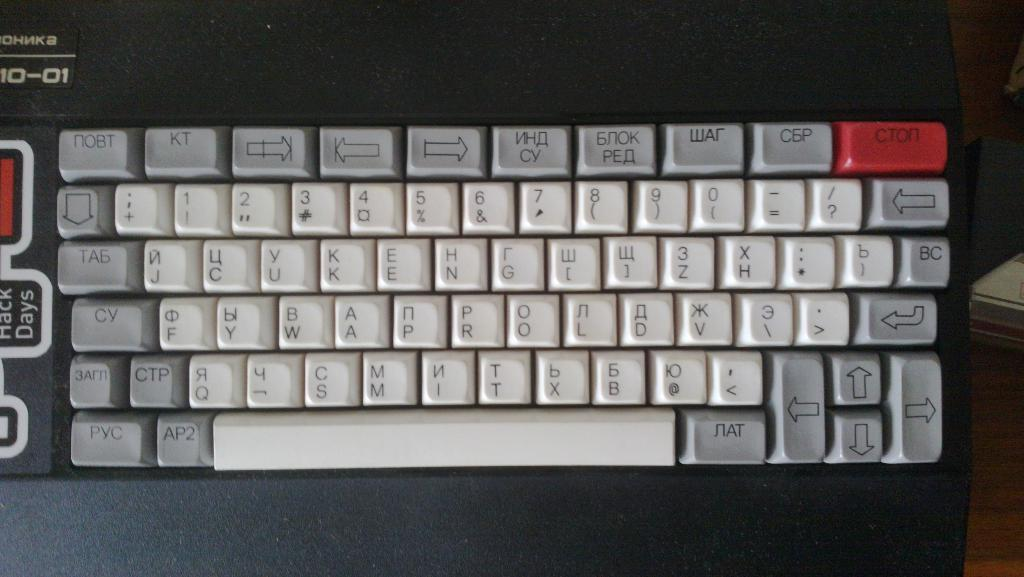<image>
Create a compact narrative representing the image presented. a keyboard shows keys like D and V along with cyrillic letters 